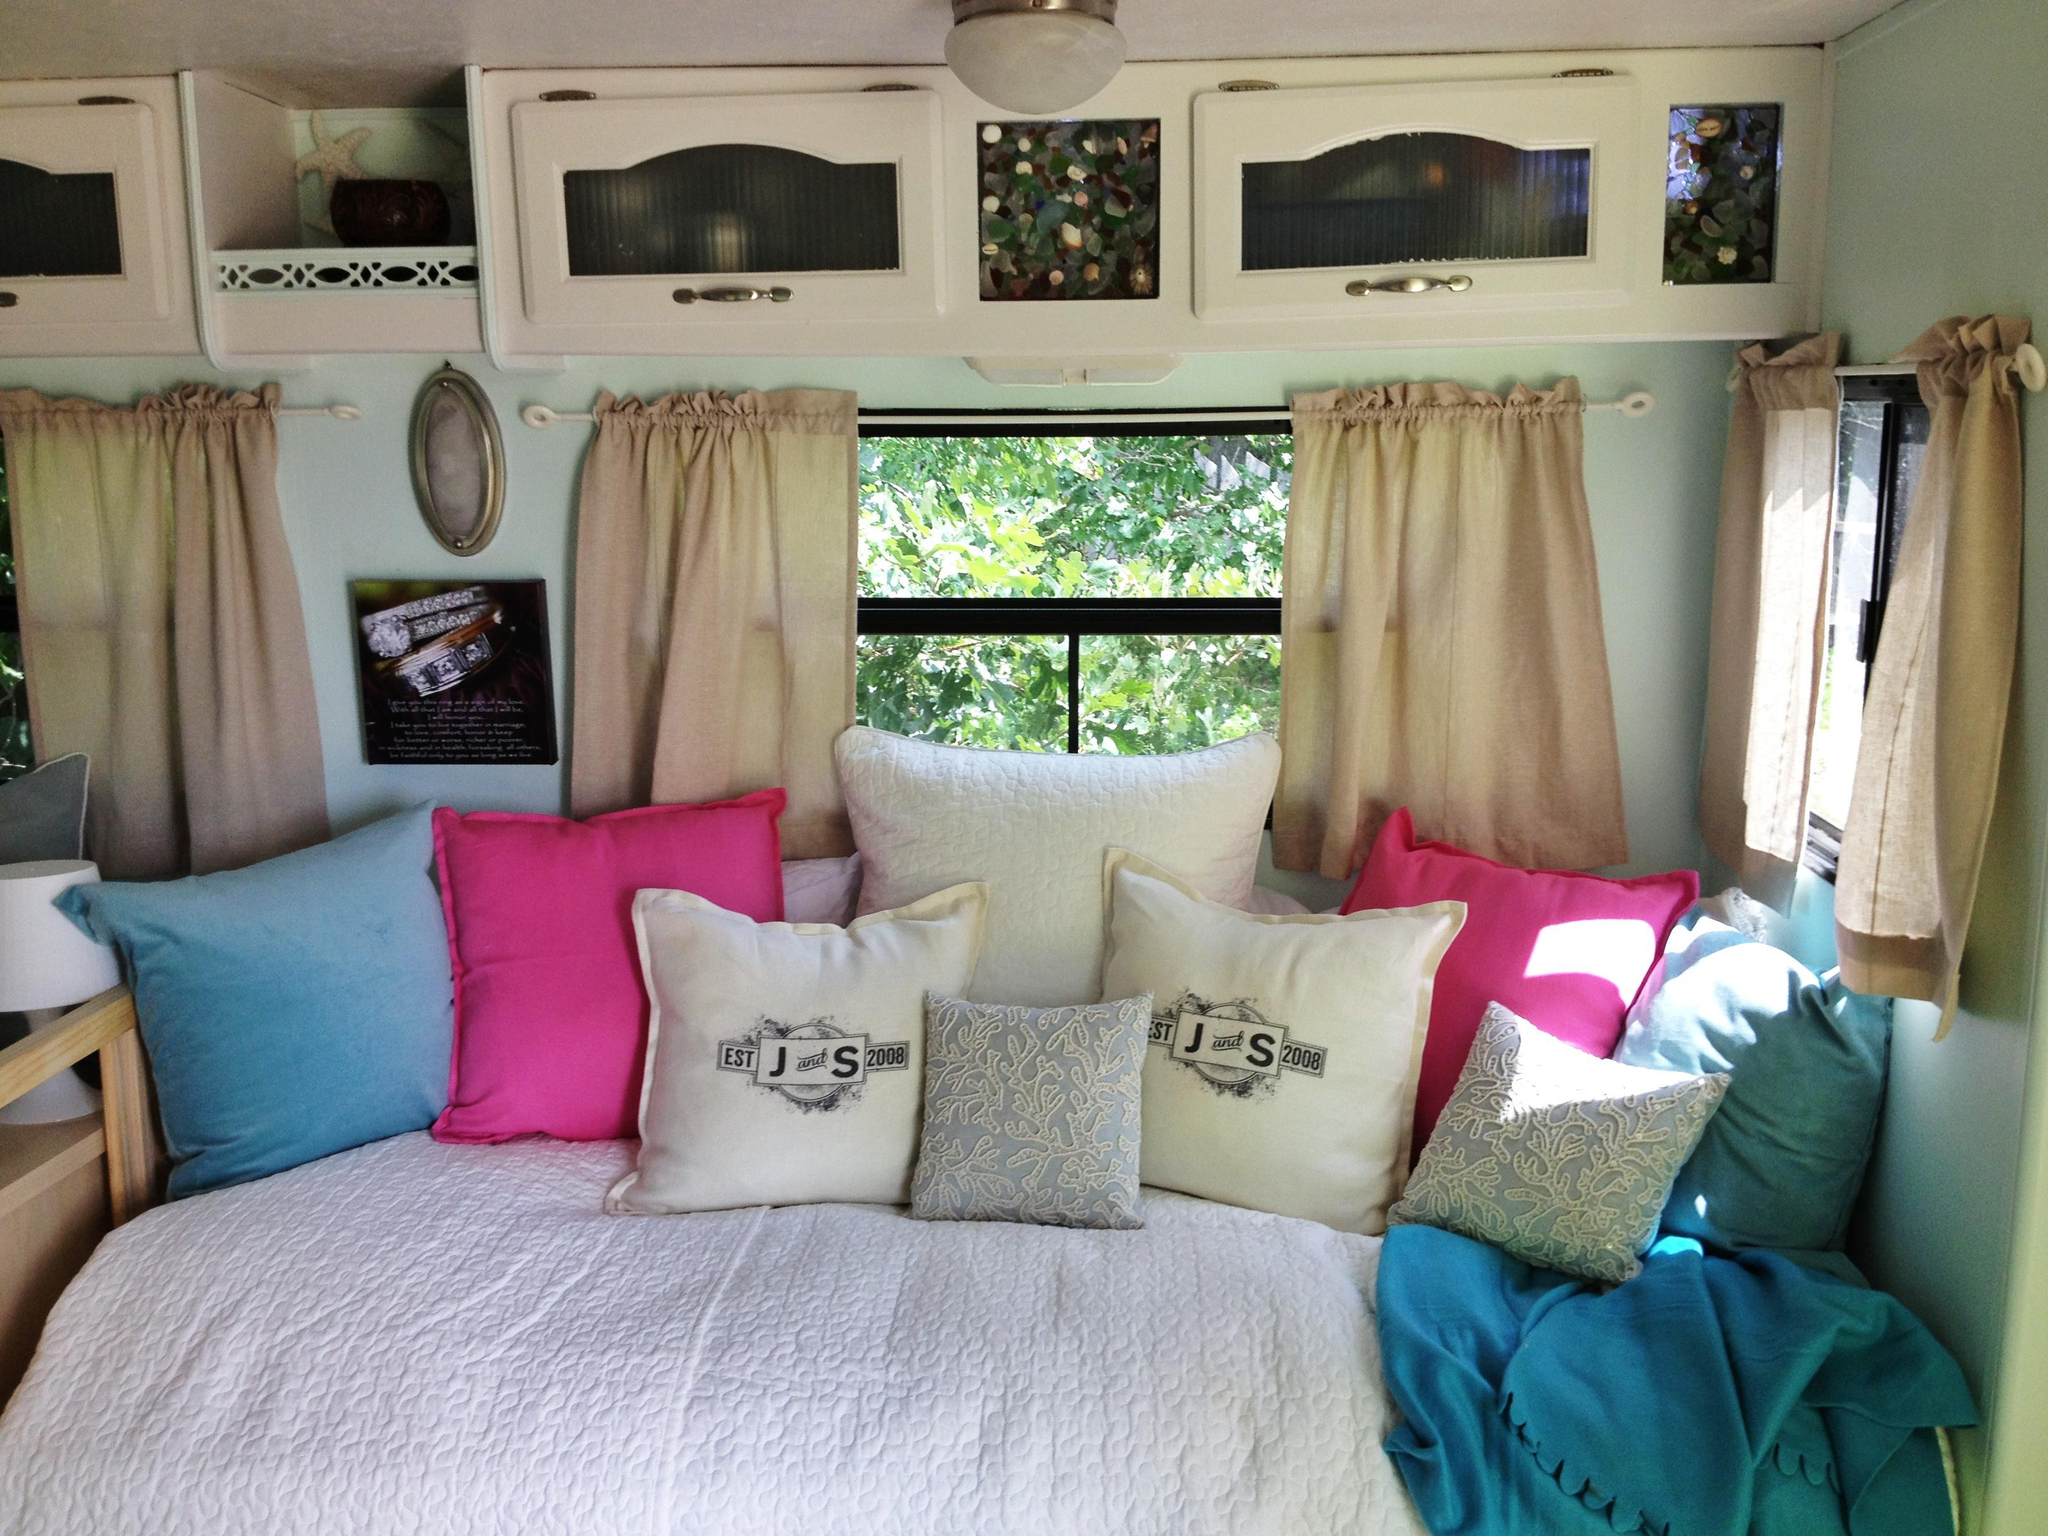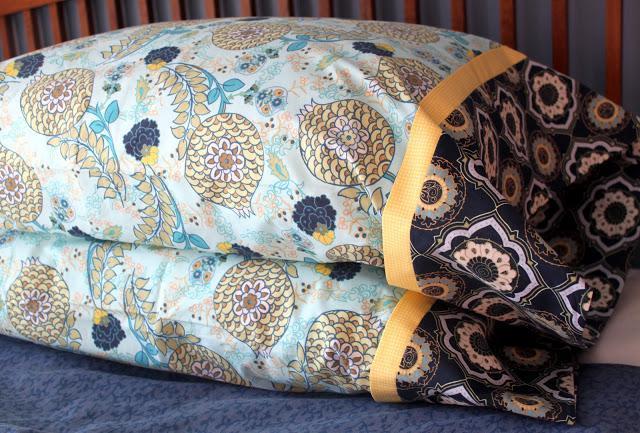The first image is the image on the left, the second image is the image on the right. Considering the images on both sides, is "There are more pillows in the left image than in the right image." valid? Answer yes or no. Yes. The first image is the image on the left, the second image is the image on the right. Assess this claim about the two images: "There are there different pillows sitting in a row on top of a cream colored sofa.". Correct or not? Answer yes or no. No. 